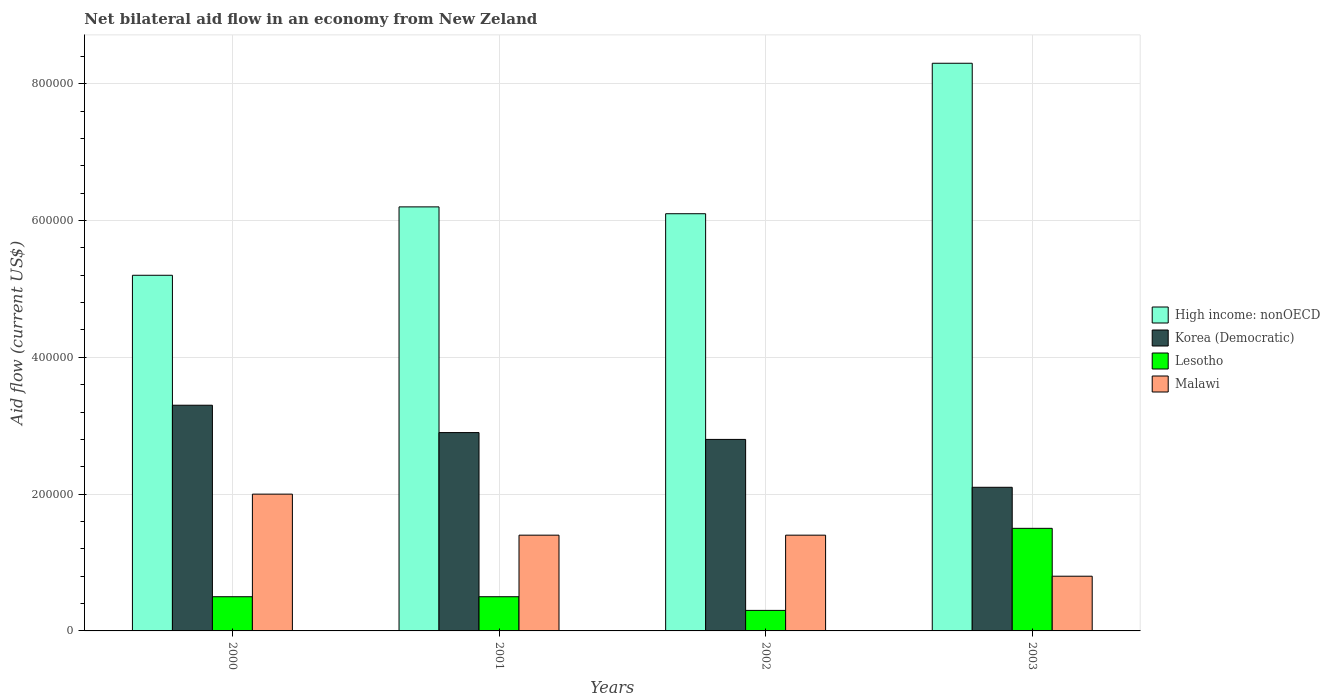How many groups of bars are there?
Offer a terse response. 4. Are the number of bars on each tick of the X-axis equal?
Provide a succinct answer. Yes. How many bars are there on the 1st tick from the left?
Make the answer very short. 4. How many bars are there on the 2nd tick from the right?
Make the answer very short. 4. What is the net bilateral aid flow in Malawi in 2002?
Make the answer very short. 1.40e+05. Across all years, what is the maximum net bilateral aid flow in Korea (Democratic)?
Offer a very short reply. 3.30e+05. Across all years, what is the minimum net bilateral aid flow in Lesotho?
Provide a short and direct response. 3.00e+04. What is the difference between the net bilateral aid flow in Korea (Democratic) in 2000 and the net bilateral aid flow in High income: nonOECD in 2003?
Offer a very short reply. -5.00e+05. What is the average net bilateral aid flow in Malawi per year?
Your answer should be very brief. 1.40e+05. In the year 2000, what is the difference between the net bilateral aid flow in Korea (Democratic) and net bilateral aid flow in High income: nonOECD?
Your answer should be compact. -1.90e+05. In how many years, is the net bilateral aid flow in Malawi greater than 600000 US$?
Make the answer very short. 0. What is the ratio of the net bilateral aid flow in High income: nonOECD in 2000 to that in 2002?
Offer a terse response. 0.85. Is the difference between the net bilateral aid flow in Korea (Democratic) in 2000 and 2002 greater than the difference between the net bilateral aid flow in High income: nonOECD in 2000 and 2002?
Your answer should be very brief. Yes. What is the difference between the highest and the second highest net bilateral aid flow in Lesotho?
Offer a very short reply. 1.00e+05. What is the difference between the highest and the lowest net bilateral aid flow in Malawi?
Make the answer very short. 1.20e+05. In how many years, is the net bilateral aid flow in Malawi greater than the average net bilateral aid flow in Malawi taken over all years?
Keep it short and to the point. 1. Is it the case that in every year, the sum of the net bilateral aid flow in High income: nonOECD and net bilateral aid flow in Malawi is greater than the sum of net bilateral aid flow in Korea (Democratic) and net bilateral aid flow in Lesotho?
Make the answer very short. No. What does the 2nd bar from the left in 2000 represents?
Offer a very short reply. Korea (Democratic). What does the 1st bar from the right in 2002 represents?
Your answer should be compact. Malawi. Is it the case that in every year, the sum of the net bilateral aid flow in Lesotho and net bilateral aid flow in High income: nonOECD is greater than the net bilateral aid flow in Malawi?
Offer a terse response. Yes. How many years are there in the graph?
Offer a terse response. 4. What is the difference between two consecutive major ticks on the Y-axis?
Your response must be concise. 2.00e+05. Does the graph contain grids?
Provide a succinct answer. Yes. How are the legend labels stacked?
Your answer should be very brief. Vertical. What is the title of the graph?
Ensure brevity in your answer.  Net bilateral aid flow in an economy from New Zeland. What is the Aid flow (current US$) of High income: nonOECD in 2000?
Keep it short and to the point. 5.20e+05. What is the Aid flow (current US$) of Malawi in 2000?
Your response must be concise. 2.00e+05. What is the Aid flow (current US$) of High income: nonOECD in 2001?
Give a very brief answer. 6.20e+05. What is the Aid flow (current US$) in Malawi in 2001?
Offer a very short reply. 1.40e+05. What is the Aid flow (current US$) of High income: nonOECD in 2002?
Ensure brevity in your answer.  6.10e+05. What is the Aid flow (current US$) of Lesotho in 2002?
Make the answer very short. 3.00e+04. What is the Aid flow (current US$) in High income: nonOECD in 2003?
Offer a very short reply. 8.30e+05. What is the Aid flow (current US$) of Korea (Democratic) in 2003?
Your response must be concise. 2.10e+05. Across all years, what is the maximum Aid flow (current US$) in High income: nonOECD?
Your answer should be compact. 8.30e+05. Across all years, what is the maximum Aid flow (current US$) in Korea (Democratic)?
Your response must be concise. 3.30e+05. Across all years, what is the maximum Aid flow (current US$) of Lesotho?
Your response must be concise. 1.50e+05. Across all years, what is the maximum Aid flow (current US$) in Malawi?
Your answer should be very brief. 2.00e+05. Across all years, what is the minimum Aid flow (current US$) of High income: nonOECD?
Ensure brevity in your answer.  5.20e+05. Across all years, what is the minimum Aid flow (current US$) in Malawi?
Your response must be concise. 8.00e+04. What is the total Aid flow (current US$) in High income: nonOECD in the graph?
Offer a terse response. 2.58e+06. What is the total Aid flow (current US$) of Korea (Democratic) in the graph?
Give a very brief answer. 1.11e+06. What is the total Aid flow (current US$) of Lesotho in the graph?
Offer a very short reply. 2.80e+05. What is the total Aid flow (current US$) of Malawi in the graph?
Offer a terse response. 5.60e+05. What is the difference between the Aid flow (current US$) of High income: nonOECD in 2000 and that in 2001?
Offer a very short reply. -1.00e+05. What is the difference between the Aid flow (current US$) of Korea (Democratic) in 2000 and that in 2001?
Your answer should be compact. 4.00e+04. What is the difference between the Aid flow (current US$) of Lesotho in 2000 and that in 2001?
Provide a short and direct response. 0. What is the difference between the Aid flow (current US$) of Malawi in 2000 and that in 2001?
Keep it short and to the point. 6.00e+04. What is the difference between the Aid flow (current US$) of High income: nonOECD in 2000 and that in 2002?
Offer a very short reply. -9.00e+04. What is the difference between the Aid flow (current US$) in High income: nonOECD in 2000 and that in 2003?
Your answer should be compact. -3.10e+05. What is the difference between the Aid flow (current US$) in Korea (Democratic) in 2000 and that in 2003?
Ensure brevity in your answer.  1.20e+05. What is the difference between the Aid flow (current US$) in Malawi in 2000 and that in 2003?
Your answer should be very brief. 1.20e+05. What is the difference between the Aid flow (current US$) in High income: nonOECD in 2001 and that in 2002?
Offer a very short reply. 10000. What is the difference between the Aid flow (current US$) in Lesotho in 2001 and that in 2002?
Your answer should be very brief. 2.00e+04. What is the difference between the Aid flow (current US$) in High income: nonOECD in 2001 and that in 2003?
Keep it short and to the point. -2.10e+05. What is the difference between the Aid flow (current US$) of Lesotho in 2001 and that in 2003?
Make the answer very short. -1.00e+05. What is the difference between the Aid flow (current US$) in Malawi in 2001 and that in 2003?
Ensure brevity in your answer.  6.00e+04. What is the difference between the Aid flow (current US$) of High income: nonOECD in 2002 and that in 2003?
Provide a succinct answer. -2.20e+05. What is the difference between the Aid flow (current US$) of Malawi in 2002 and that in 2003?
Keep it short and to the point. 6.00e+04. What is the difference between the Aid flow (current US$) of High income: nonOECD in 2000 and the Aid flow (current US$) of Korea (Democratic) in 2001?
Keep it short and to the point. 2.30e+05. What is the difference between the Aid flow (current US$) of High income: nonOECD in 2000 and the Aid flow (current US$) of Malawi in 2001?
Your answer should be compact. 3.80e+05. What is the difference between the Aid flow (current US$) of Korea (Democratic) in 2000 and the Aid flow (current US$) of Malawi in 2001?
Ensure brevity in your answer.  1.90e+05. What is the difference between the Aid flow (current US$) in High income: nonOECD in 2000 and the Aid flow (current US$) in Korea (Democratic) in 2002?
Keep it short and to the point. 2.40e+05. What is the difference between the Aid flow (current US$) of High income: nonOECD in 2000 and the Aid flow (current US$) of Lesotho in 2002?
Make the answer very short. 4.90e+05. What is the difference between the Aid flow (current US$) in Korea (Democratic) in 2000 and the Aid flow (current US$) in Lesotho in 2002?
Offer a very short reply. 3.00e+05. What is the difference between the Aid flow (current US$) in Lesotho in 2000 and the Aid flow (current US$) in Malawi in 2002?
Your answer should be compact. -9.00e+04. What is the difference between the Aid flow (current US$) of High income: nonOECD in 2000 and the Aid flow (current US$) of Malawi in 2003?
Provide a short and direct response. 4.40e+05. What is the difference between the Aid flow (current US$) in Korea (Democratic) in 2000 and the Aid flow (current US$) in Lesotho in 2003?
Your response must be concise. 1.80e+05. What is the difference between the Aid flow (current US$) in High income: nonOECD in 2001 and the Aid flow (current US$) in Lesotho in 2002?
Your answer should be compact. 5.90e+05. What is the difference between the Aid flow (current US$) in Korea (Democratic) in 2001 and the Aid flow (current US$) in Lesotho in 2002?
Give a very brief answer. 2.60e+05. What is the difference between the Aid flow (current US$) in Lesotho in 2001 and the Aid flow (current US$) in Malawi in 2002?
Ensure brevity in your answer.  -9.00e+04. What is the difference between the Aid flow (current US$) in High income: nonOECD in 2001 and the Aid flow (current US$) in Korea (Democratic) in 2003?
Offer a very short reply. 4.10e+05. What is the difference between the Aid flow (current US$) in High income: nonOECD in 2001 and the Aid flow (current US$) in Malawi in 2003?
Your answer should be compact. 5.40e+05. What is the difference between the Aid flow (current US$) in Korea (Democratic) in 2001 and the Aid flow (current US$) in Lesotho in 2003?
Ensure brevity in your answer.  1.40e+05. What is the difference between the Aid flow (current US$) of Korea (Democratic) in 2001 and the Aid flow (current US$) of Malawi in 2003?
Provide a succinct answer. 2.10e+05. What is the difference between the Aid flow (current US$) of Lesotho in 2001 and the Aid flow (current US$) of Malawi in 2003?
Offer a very short reply. -3.00e+04. What is the difference between the Aid flow (current US$) in High income: nonOECD in 2002 and the Aid flow (current US$) in Korea (Democratic) in 2003?
Provide a succinct answer. 4.00e+05. What is the difference between the Aid flow (current US$) in High income: nonOECD in 2002 and the Aid flow (current US$) in Malawi in 2003?
Provide a short and direct response. 5.30e+05. What is the difference between the Aid flow (current US$) of Korea (Democratic) in 2002 and the Aid flow (current US$) of Lesotho in 2003?
Your answer should be very brief. 1.30e+05. What is the difference between the Aid flow (current US$) of Korea (Democratic) in 2002 and the Aid flow (current US$) of Malawi in 2003?
Your answer should be very brief. 2.00e+05. What is the difference between the Aid flow (current US$) of Lesotho in 2002 and the Aid flow (current US$) of Malawi in 2003?
Keep it short and to the point. -5.00e+04. What is the average Aid flow (current US$) in High income: nonOECD per year?
Provide a short and direct response. 6.45e+05. What is the average Aid flow (current US$) in Korea (Democratic) per year?
Your answer should be compact. 2.78e+05. What is the average Aid flow (current US$) in Malawi per year?
Make the answer very short. 1.40e+05. In the year 2000, what is the difference between the Aid flow (current US$) in High income: nonOECD and Aid flow (current US$) in Korea (Democratic)?
Ensure brevity in your answer.  1.90e+05. In the year 2000, what is the difference between the Aid flow (current US$) in High income: nonOECD and Aid flow (current US$) in Lesotho?
Your response must be concise. 4.70e+05. In the year 2000, what is the difference between the Aid flow (current US$) of High income: nonOECD and Aid flow (current US$) of Malawi?
Your answer should be compact. 3.20e+05. In the year 2000, what is the difference between the Aid flow (current US$) of Korea (Democratic) and Aid flow (current US$) of Malawi?
Keep it short and to the point. 1.30e+05. In the year 2001, what is the difference between the Aid flow (current US$) in High income: nonOECD and Aid flow (current US$) in Korea (Democratic)?
Ensure brevity in your answer.  3.30e+05. In the year 2001, what is the difference between the Aid flow (current US$) in High income: nonOECD and Aid flow (current US$) in Lesotho?
Make the answer very short. 5.70e+05. In the year 2001, what is the difference between the Aid flow (current US$) in High income: nonOECD and Aid flow (current US$) in Malawi?
Provide a short and direct response. 4.80e+05. In the year 2002, what is the difference between the Aid flow (current US$) of High income: nonOECD and Aid flow (current US$) of Korea (Democratic)?
Make the answer very short. 3.30e+05. In the year 2002, what is the difference between the Aid flow (current US$) of High income: nonOECD and Aid flow (current US$) of Lesotho?
Make the answer very short. 5.80e+05. In the year 2002, what is the difference between the Aid flow (current US$) in Korea (Democratic) and Aid flow (current US$) in Malawi?
Your answer should be very brief. 1.40e+05. In the year 2003, what is the difference between the Aid flow (current US$) in High income: nonOECD and Aid flow (current US$) in Korea (Democratic)?
Your answer should be very brief. 6.20e+05. In the year 2003, what is the difference between the Aid flow (current US$) in High income: nonOECD and Aid flow (current US$) in Lesotho?
Your answer should be compact. 6.80e+05. In the year 2003, what is the difference between the Aid flow (current US$) of High income: nonOECD and Aid flow (current US$) of Malawi?
Ensure brevity in your answer.  7.50e+05. In the year 2003, what is the difference between the Aid flow (current US$) in Korea (Democratic) and Aid flow (current US$) in Lesotho?
Your answer should be very brief. 6.00e+04. In the year 2003, what is the difference between the Aid flow (current US$) of Korea (Democratic) and Aid flow (current US$) of Malawi?
Offer a terse response. 1.30e+05. What is the ratio of the Aid flow (current US$) in High income: nonOECD in 2000 to that in 2001?
Give a very brief answer. 0.84. What is the ratio of the Aid flow (current US$) of Korea (Democratic) in 2000 to that in 2001?
Make the answer very short. 1.14. What is the ratio of the Aid flow (current US$) in Malawi in 2000 to that in 2001?
Ensure brevity in your answer.  1.43. What is the ratio of the Aid flow (current US$) of High income: nonOECD in 2000 to that in 2002?
Your response must be concise. 0.85. What is the ratio of the Aid flow (current US$) in Korea (Democratic) in 2000 to that in 2002?
Provide a succinct answer. 1.18. What is the ratio of the Aid flow (current US$) of Malawi in 2000 to that in 2002?
Provide a short and direct response. 1.43. What is the ratio of the Aid flow (current US$) of High income: nonOECD in 2000 to that in 2003?
Give a very brief answer. 0.63. What is the ratio of the Aid flow (current US$) of Korea (Democratic) in 2000 to that in 2003?
Offer a very short reply. 1.57. What is the ratio of the Aid flow (current US$) in Lesotho in 2000 to that in 2003?
Give a very brief answer. 0.33. What is the ratio of the Aid flow (current US$) of High income: nonOECD in 2001 to that in 2002?
Your response must be concise. 1.02. What is the ratio of the Aid flow (current US$) of Korea (Democratic) in 2001 to that in 2002?
Your answer should be very brief. 1.04. What is the ratio of the Aid flow (current US$) of Lesotho in 2001 to that in 2002?
Give a very brief answer. 1.67. What is the ratio of the Aid flow (current US$) in High income: nonOECD in 2001 to that in 2003?
Ensure brevity in your answer.  0.75. What is the ratio of the Aid flow (current US$) in Korea (Democratic) in 2001 to that in 2003?
Keep it short and to the point. 1.38. What is the ratio of the Aid flow (current US$) in High income: nonOECD in 2002 to that in 2003?
Provide a succinct answer. 0.73. What is the ratio of the Aid flow (current US$) in Malawi in 2002 to that in 2003?
Your answer should be compact. 1.75. What is the difference between the highest and the second highest Aid flow (current US$) in High income: nonOECD?
Provide a short and direct response. 2.10e+05. What is the difference between the highest and the second highest Aid flow (current US$) of Malawi?
Make the answer very short. 6.00e+04. What is the difference between the highest and the lowest Aid flow (current US$) in High income: nonOECD?
Make the answer very short. 3.10e+05. What is the difference between the highest and the lowest Aid flow (current US$) in Korea (Democratic)?
Ensure brevity in your answer.  1.20e+05. What is the difference between the highest and the lowest Aid flow (current US$) in Malawi?
Give a very brief answer. 1.20e+05. 